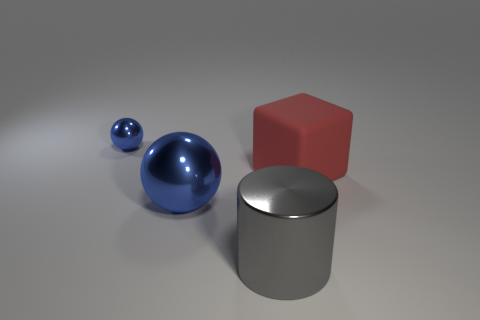Add 4 small spheres. How many objects exist? 8 Subtract all cubes. How many objects are left? 3 Add 2 large metallic things. How many large metallic things are left? 4 Add 4 red objects. How many red objects exist? 5 Subtract 0 green cylinders. How many objects are left? 4 Subtract all big blue spheres. Subtract all large things. How many objects are left? 0 